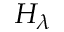Convert formula to latex. <formula><loc_0><loc_0><loc_500><loc_500>H _ { \lambda }</formula> 